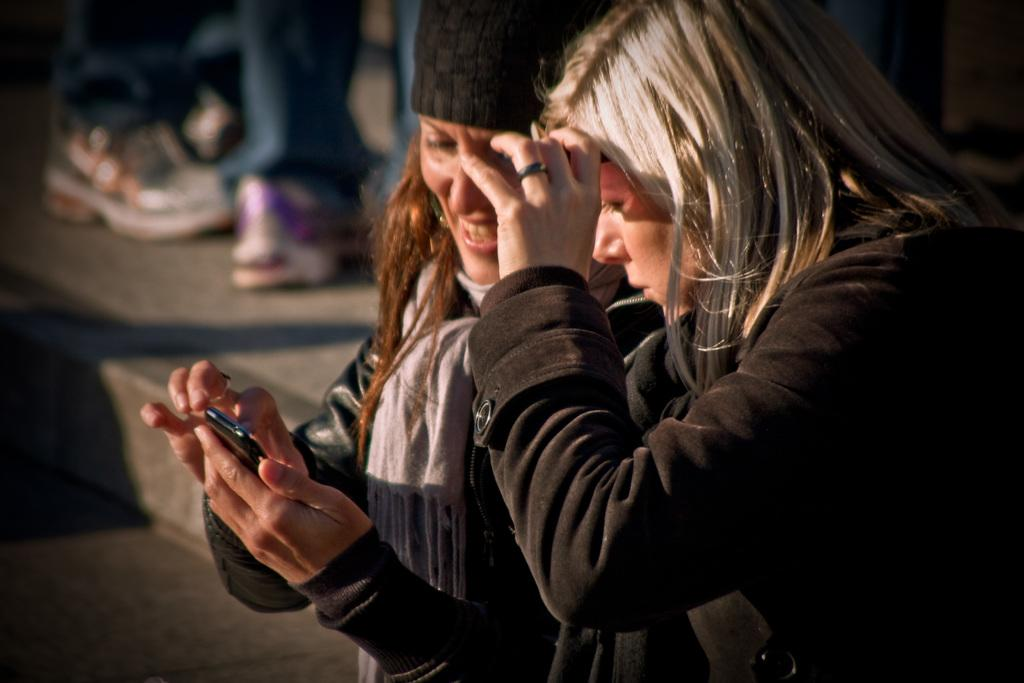What is the person in the image holding? The person in the image is holding a mobile. Can you describe the other person in the image? There is another person beside the first person. What can be seen in the background of the image? There are legs of a few people visible on a platform in the background. What type of map is the person holding in the image? The person is not holding a map in the image; they are holding a mobile. How does the head of the person beside the first person look like? The image does not show the heads of the people, only their legs are visible on the platform. 